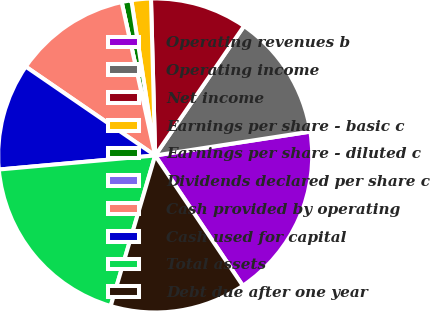Convert chart to OTSL. <chart><loc_0><loc_0><loc_500><loc_500><pie_chart><fcel>Operating revenues b<fcel>Operating income<fcel>Net income<fcel>Earnings per share - basic c<fcel>Earnings per share - diluted c<fcel>Dividends declared per share c<fcel>Cash provided by operating<fcel>Cash used for capital<fcel>Total assets<fcel>Debt due after one year<nl><fcel>18.0%<fcel>13.0%<fcel>10.0%<fcel>2.0%<fcel>1.0%<fcel>0.0%<fcel>12.0%<fcel>11.0%<fcel>19.0%<fcel>14.0%<nl></chart> 